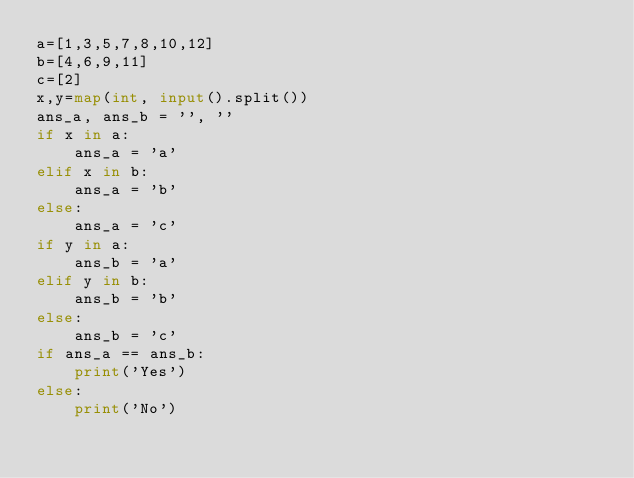Convert code to text. <code><loc_0><loc_0><loc_500><loc_500><_Python_>a=[1,3,5,7,8,10,12]
b=[4,6,9,11]
c=[2]
x,y=map(int, input().split())
ans_a, ans_b = '', ''
if x in a:
    ans_a = 'a'
elif x in b:
    ans_a = 'b'
else:
    ans_a = 'c'
if y in a:
    ans_b = 'a'
elif y in b:
    ans_b = 'b'
else:
    ans_b = 'c'
if ans_a == ans_b:
    print('Yes')
else:
    print('No')
</code> 